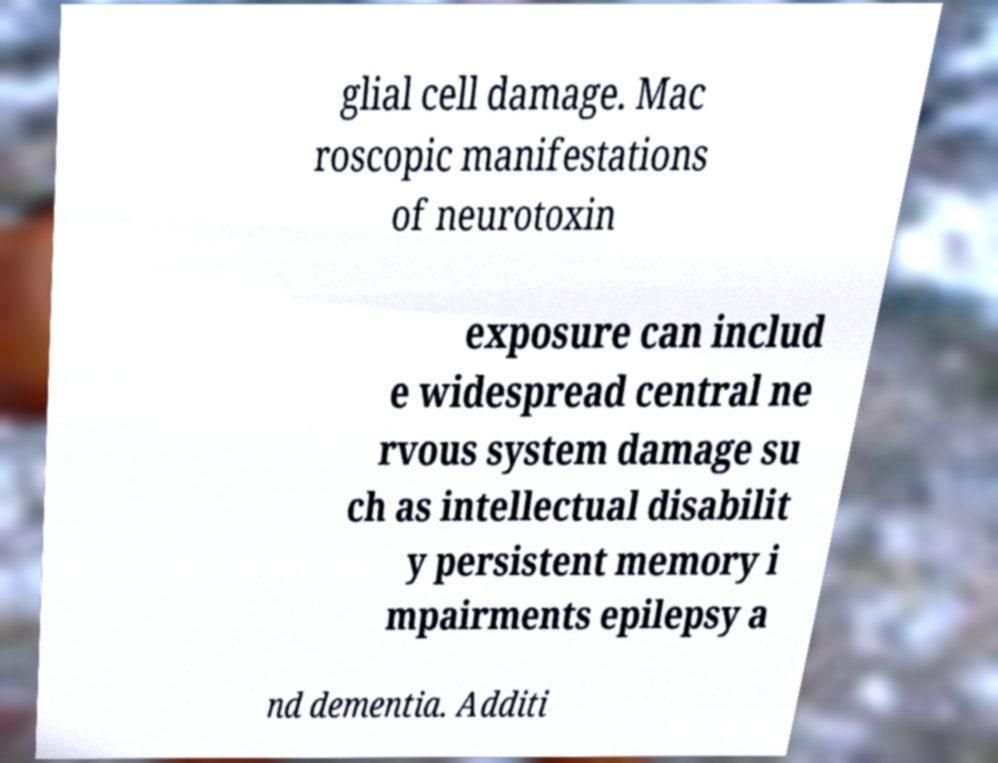Please identify and transcribe the text found in this image. glial cell damage. Mac roscopic manifestations of neurotoxin exposure can includ e widespread central ne rvous system damage su ch as intellectual disabilit y persistent memory i mpairments epilepsy a nd dementia. Additi 